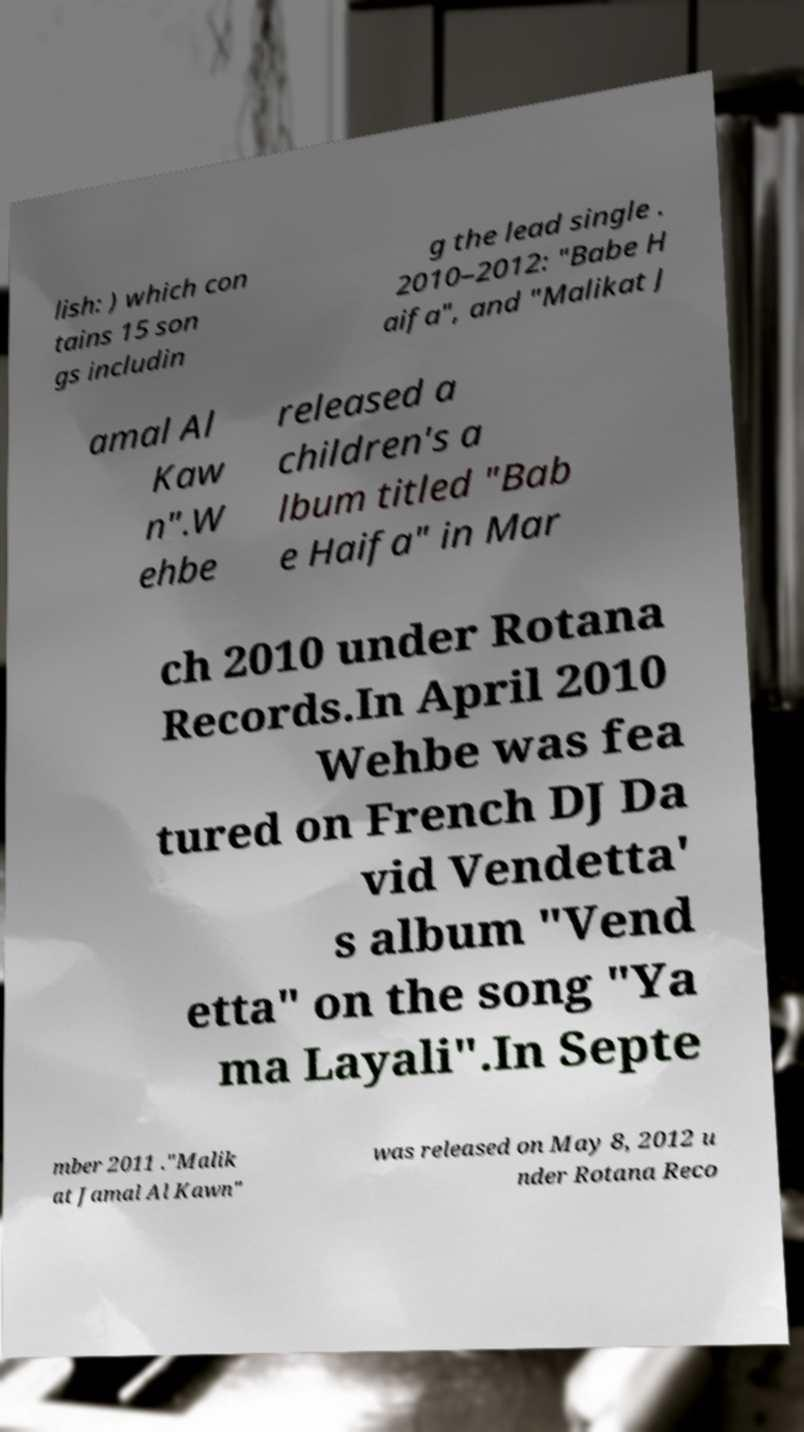I need the written content from this picture converted into text. Can you do that? lish: ) which con tains 15 son gs includin g the lead single . 2010–2012: "Babe H aifa", and "Malikat J amal Al Kaw n".W ehbe released a children's a lbum titled "Bab e Haifa" in Mar ch 2010 under Rotana Records.In April 2010 Wehbe was fea tured on French DJ Da vid Vendetta' s album "Vend etta" on the song "Ya ma Layali".In Septe mber 2011 ."Malik at Jamal Al Kawn" was released on May 8, 2012 u nder Rotana Reco 